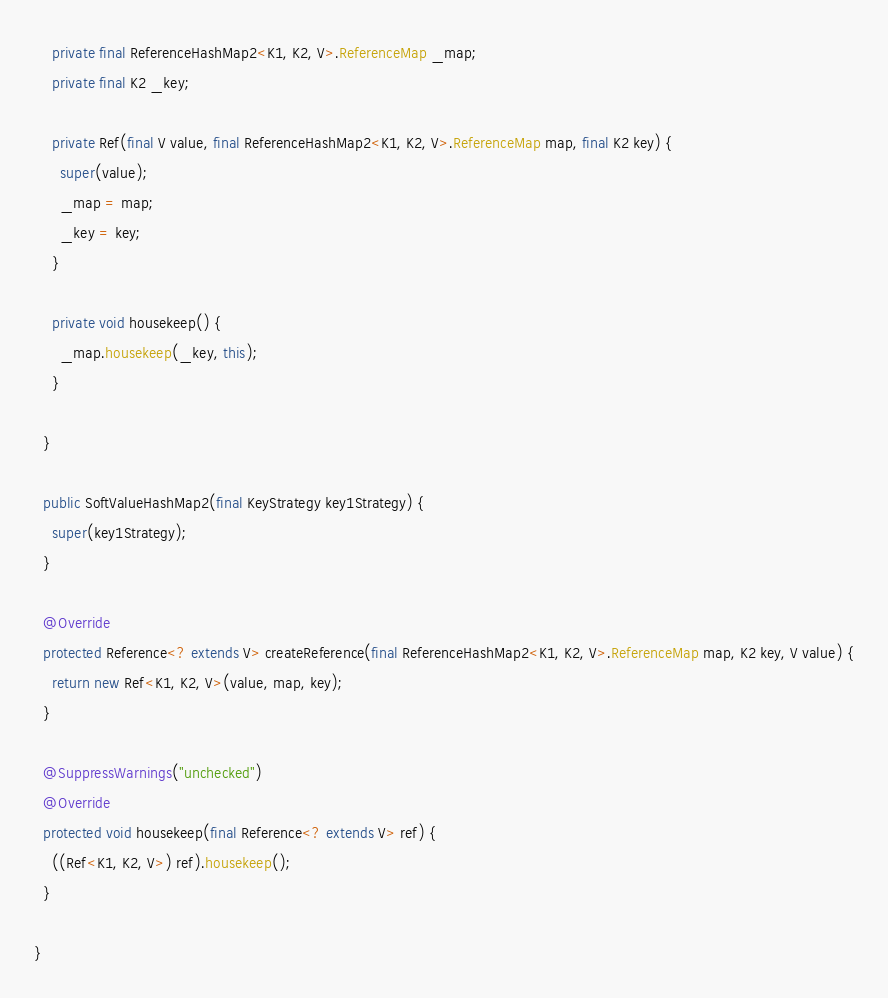<code> <loc_0><loc_0><loc_500><loc_500><_Java_>
    private final ReferenceHashMap2<K1, K2, V>.ReferenceMap _map;
    private final K2 _key;

    private Ref(final V value, final ReferenceHashMap2<K1, K2, V>.ReferenceMap map, final K2 key) {
      super(value);
      _map = map;
      _key = key;
    }

    private void housekeep() {
      _map.housekeep(_key, this);
    }

  }

  public SoftValueHashMap2(final KeyStrategy key1Strategy) {
    super(key1Strategy);
  }

  @Override
  protected Reference<? extends V> createReference(final ReferenceHashMap2<K1, K2, V>.ReferenceMap map, K2 key, V value) {
    return new Ref<K1, K2, V>(value, map, key);
  }

  @SuppressWarnings("unchecked")
  @Override
  protected void housekeep(final Reference<? extends V> ref) {
    ((Ref<K1, K2, V>) ref).housekeep();
  }

}
</code> 